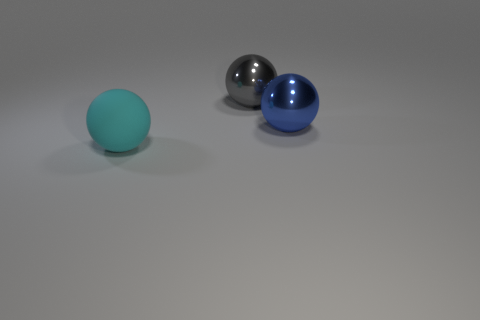Are there any other things that are made of the same material as the cyan ball?
Make the answer very short. No. What number of objects are big objects that are behind the big cyan sphere or large balls that are left of the gray metallic sphere?
Your answer should be very brief. 3. How many things are either big blue shiny things or small purple cubes?
Offer a very short reply. 1. There is a ball that is both right of the cyan object and in front of the gray shiny object; what is its size?
Provide a succinct answer. Large. What number of big balls have the same material as the large gray thing?
Keep it short and to the point. 1. What color is the other big sphere that is the same material as the gray ball?
Provide a succinct answer. Blue. There is a big sphere that is on the left side of the big gray ball; what is it made of?
Offer a terse response. Rubber. Are there the same number of big cyan matte things that are in front of the large gray metal thing and green metallic cubes?
Ensure brevity in your answer.  No. The other metal thing that is the same shape as the big gray thing is what color?
Offer a terse response. Blue. Do the gray metallic thing and the cyan sphere have the same size?
Keep it short and to the point. Yes. 